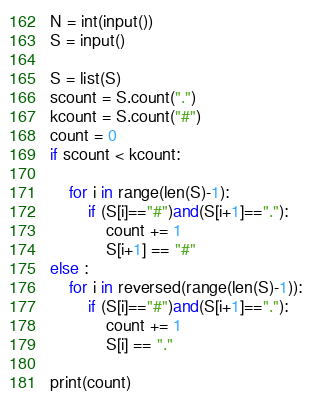Convert code to text. <code><loc_0><loc_0><loc_500><loc_500><_Python_>N = int(input())
S = input()

S = list(S)
scount = S.count(".")
kcount = S.count("#")
count = 0
if scount < kcount:

    for i in range(len(S)-1):
        if (S[i]=="#")and(S[i+1]=="."):
            count += 1
            S[i+1] == "#"
else :
    for i in reversed(range(len(S)-1)):
        if (S[i]=="#")and(S[i+1]=="."):
            count += 1
            S[i] == "."

print(count)
</code> 